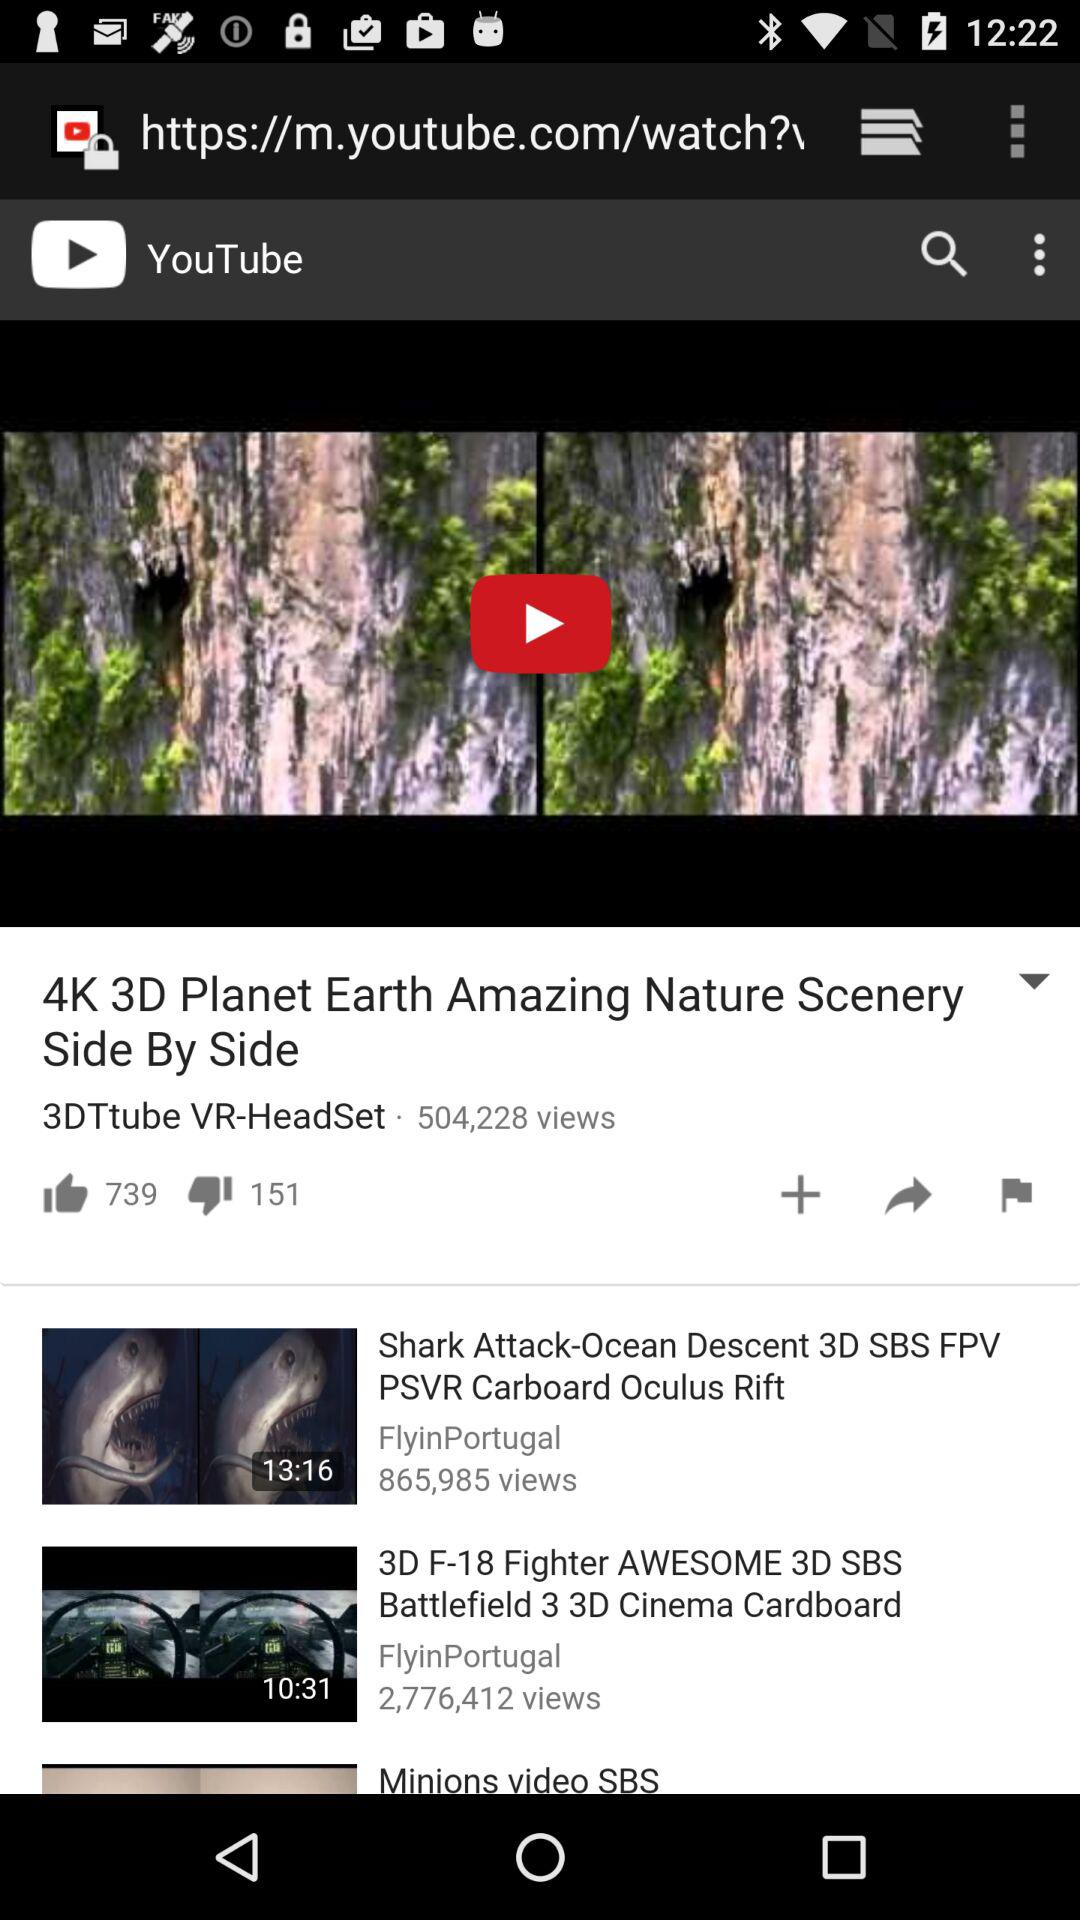What is the length of the "Shark Attack" video? The length of the "Shark Attack" video is 13 minutes and 16 seconds. 